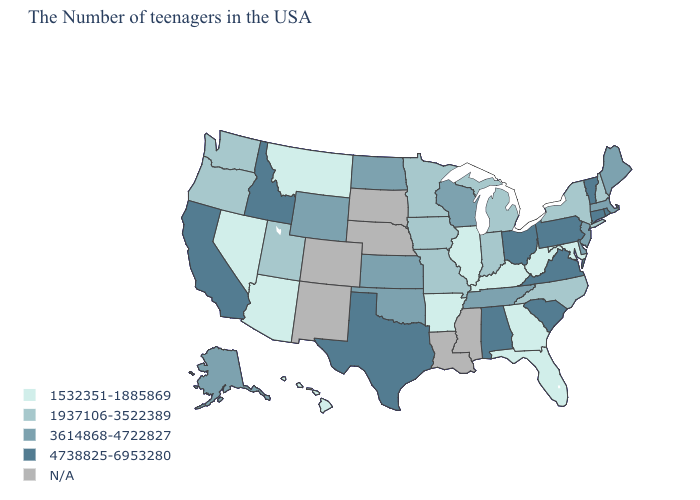What is the highest value in the South ?
Keep it brief. 4738825-6953280. Name the states that have a value in the range 3614868-4722827?
Short answer required. Maine, Massachusetts, New Jersey, Delaware, Tennessee, Wisconsin, Kansas, Oklahoma, North Dakota, Wyoming, Alaska. What is the value of Iowa?
Write a very short answer. 1937106-3522389. Does the map have missing data?
Answer briefly. Yes. Is the legend a continuous bar?
Give a very brief answer. No. What is the lowest value in the USA?
Answer briefly. 1532351-1885869. Does Ohio have the lowest value in the MidWest?
Answer briefly. No. Which states hav the highest value in the MidWest?
Give a very brief answer. Ohio. What is the value of Delaware?
Be succinct. 3614868-4722827. What is the highest value in the USA?
Write a very short answer. 4738825-6953280. Name the states that have a value in the range 3614868-4722827?
Write a very short answer. Maine, Massachusetts, New Jersey, Delaware, Tennessee, Wisconsin, Kansas, Oklahoma, North Dakota, Wyoming, Alaska. What is the value of Tennessee?
Keep it brief. 3614868-4722827. Among the states that border Texas , which have the highest value?
Give a very brief answer. Oklahoma. Does Texas have the lowest value in the USA?
Short answer required. No. What is the lowest value in the MidWest?
Keep it brief. 1532351-1885869. 